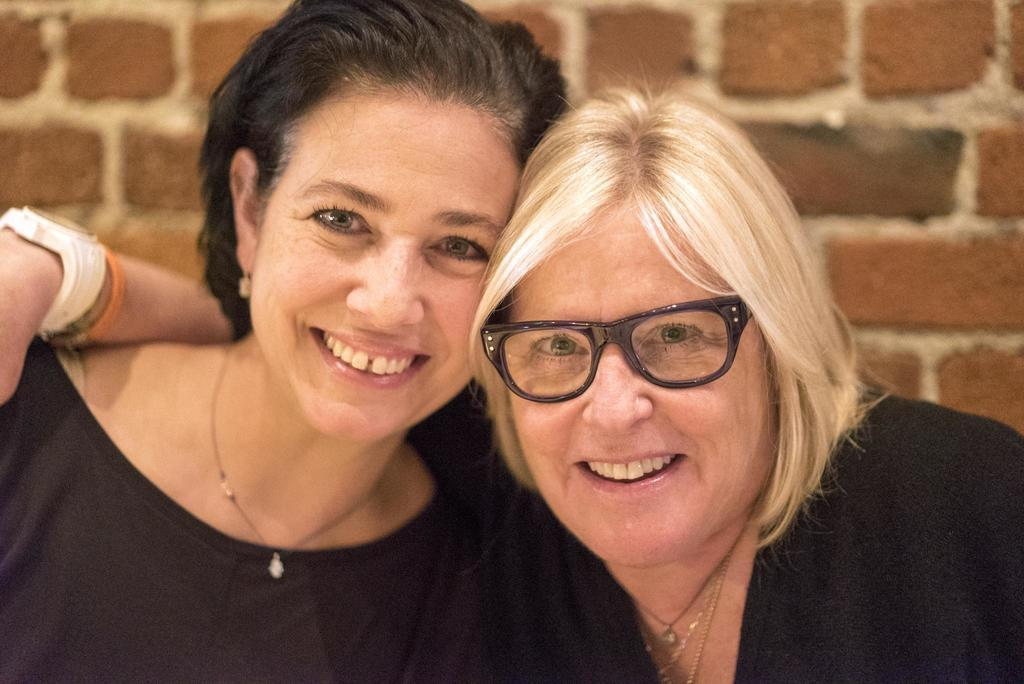How many women are present in the image? There are two women in the image. What are the women wearing? Both women are wearing black dresses. What can be seen in the background of the image? There is a brick wall in the background of the image. Are there any dinosaurs visible in the image? No, there are no dinosaurs present in the image. What role do the women play in the image, such as servant or actor? The provided facts do not mention any roles or occupations for the women in the image. 